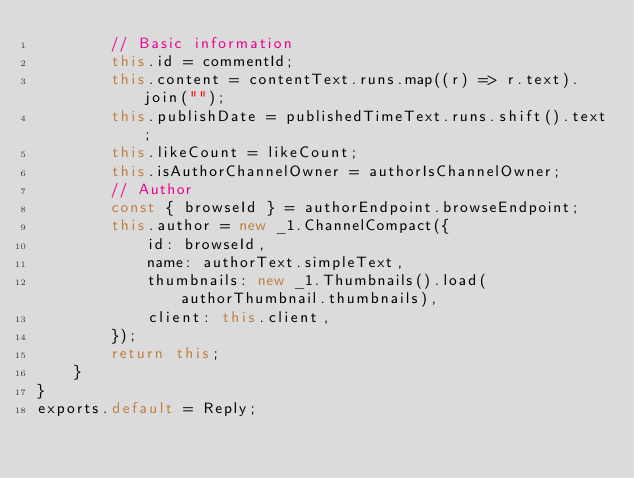Convert code to text. <code><loc_0><loc_0><loc_500><loc_500><_JavaScript_>        // Basic information
        this.id = commentId;
        this.content = contentText.runs.map((r) => r.text).join("");
        this.publishDate = publishedTimeText.runs.shift().text;
        this.likeCount = likeCount;
        this.isAuthorChannelOwner = authorIsChannelOwner;
        // Author
        const { browseId } = authorEndpoint.browseEndpoint;
        this.author = new _1.ChannelCompact({
            id: browseId,
            name: authorText.simpleText,
            thumbnails: new _1.Thumbnails().load(authorThumbnail.thumbnails),
            client: this.client,
        });
        return this;
    }
}
exports.default = Reply;
</code> 